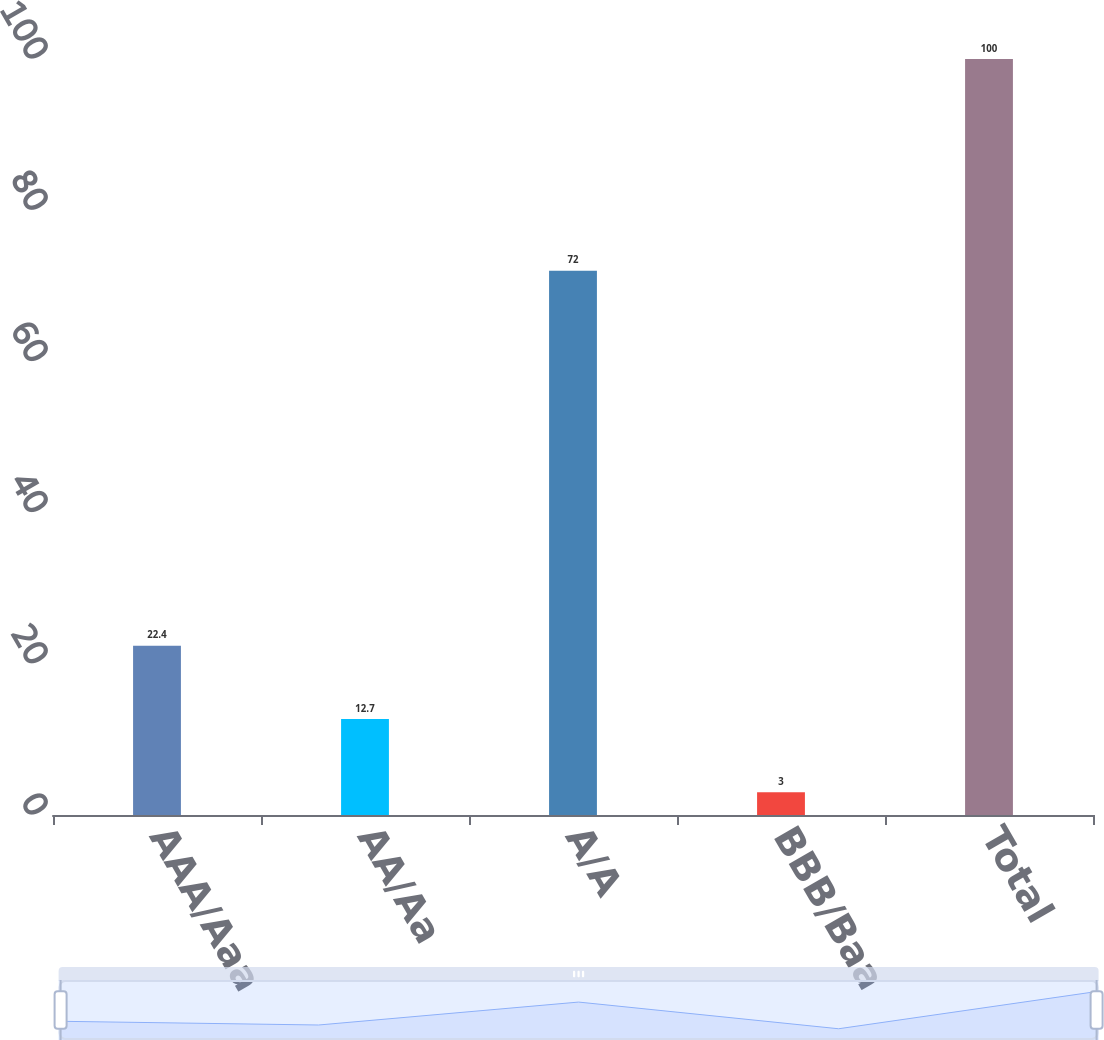Convert chart to OTSL. <chart><loc_0><loc_0><loc_500><loc_500><bar_chart><fcel>AAA/Aaa<fcel>AA/Aa<fcel>A/A<fcel>BBB/Baa<fcel>Total<nl><fcel>22.4<fcel>12.7<fcel>72<fcel>3<fcel>100<nl></chart> 